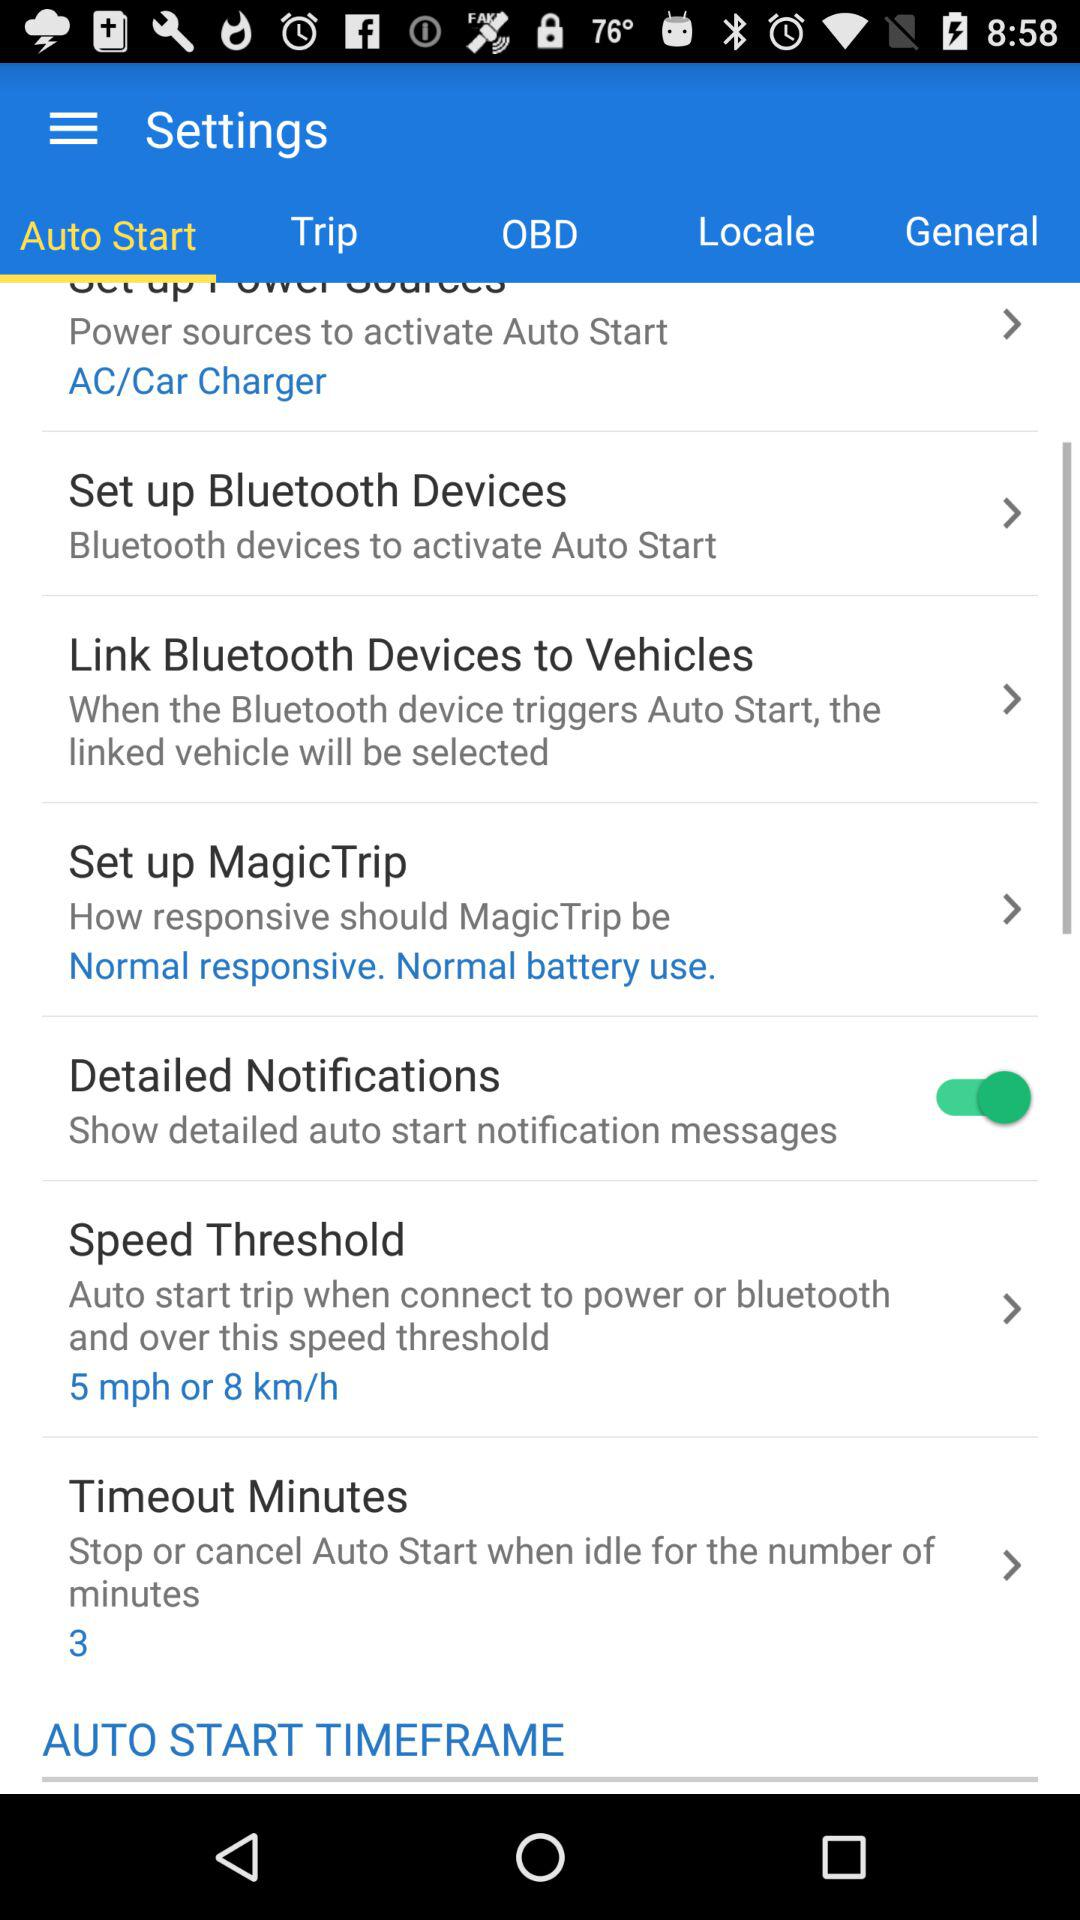What are the detailed notification settings?
When the provided information is insufficient, respond with <no answer>. <no answer> 